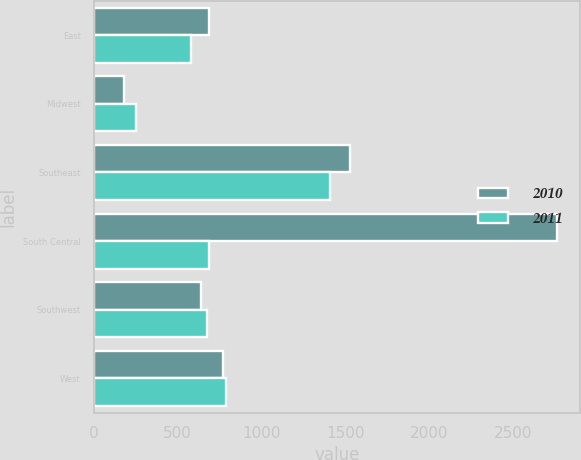<chart> <loc_0><loc_0><loc_500><loc_500><stacked_bar_chart><ecel><fcel>East<fcel>Midwest<fcel>Southeast<fcel>South Central<fcel>Southwest<fcel>West<nl><fcel>2010<fcel>689<fcel>177<fcel>1531<fcel>2763<fcel>639<fcel>769<nl><fcel>2011<fcel>581<fcel>250<fcel>1409<fcel>689<fcel>677<fcel>789<nl></chart> 